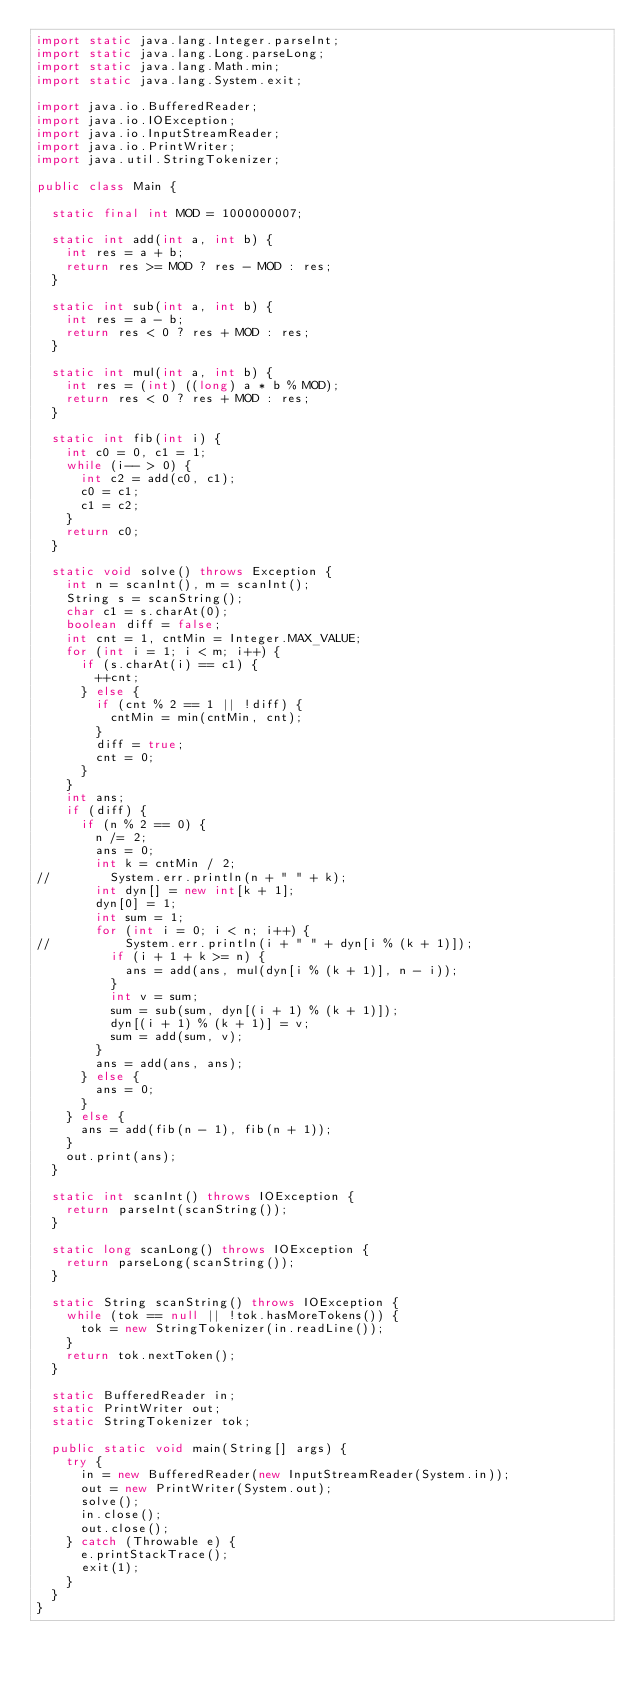<code> <loc_0><loc_0><loc_500><loc_500><_Java_>import static java.lang.Integer.parseInt;
import static java.lang.Long.parseLong;
import static java.lang.Math.min;
import static java.lang.System.exit;

import java.io.BufferedReader;
import java.io.IOException;
import java.io.InputStreamReader;
import java.io.PrintWriter;
import java.util.StringTokenizer;

public class Main {

	static final int MOD = 1000000007;

	static int add(int a, int b) {
		int res = a + b;
		return res >= MOD ? res - MOD : res;
	}

	static int sub(int a, int b) {
		int res = a - b;
		return res < 0 ? res + MOD : res;
	}

	static int mul(int a, int b) {
		int res = (int) ((long) a * b % MOD);
		return res < 0 ? res + MOD : res;
	}

	static int fib(int i) {
		int c0 = 0, c1 = 1;
		while (i-- > 0) {
			int c2 = add(c0, c1);
			c0 = c1;
			c1 = c2;
		}
		return c0;
	}

	static void solve() throws Exception {
		int n = scanInt(), m = scanInt();
		String s = scanString();
		char c1 = s.charAt(0);
		boolean diff = false;
		int cnt = 1, cntMin = Integer.MAX_VALUE;
		for (int i = 1; i < m; i++) {
			if (s.charAt(i) == c1) {
				++cnt;
			} else {
				if (cnt % 2 == 1 || !diff) {
					cntMin = min(cntMin, cnt);
				}
				diff = true;
				cnt = 0;
			}
		}
		int ans;
		if (diff) {
			if (n % 2 == 0) {
				n /= 2;
				ans = 0;
				int k = cntMin / 2;
//				System.err.println(n + " " + k);
				int dyn[] = new int[k + 1];
				dyn[0] = 1;
				int sum = 1;
				for (int i = 0; i < n; i++) {
//					System.err.println(i + " " + dyn[i % (k + 1)]);
					if (i + 1 + k >= n) {
						ans = add(ans, mul(dyn[i % (k + 1)], n - i));
					}
					int v = sum;
					sum = sub(sum, dyn[(i + 1) % (k + 1)]);
					dyn[(i + 1) % (k + 1)] = v;
					sum = add(sum, v);
				}
				ans = add(ans, ans);
			} else {
				ans = 0;
			}
		} else {
			ans = add(fib(n - 1), fib(n + 1));
		}
		out.print(ans);
	}

	static int scanInt() throws IOException {
		return parseInt(scanString());
	}

	static long scanLong() throws IOException {
		return parseLong(scanString());
	}

	static String scanString() throws IOException {
		while (tok == null || !tok.hasMoreTokens()) {
			tok = new StringTokenizer(in.readLine());
		}
		return tok.nextToken();
	}

	static BufferedReader in;
	static PrintWriter out;
	static StringTokenizer tok;

	public static void main(String[] args) {
		try {
			in = new BufferedReader(new InputStreamReader(System.in));
			out = new PrintWriter(System.out);
			solve();
			in.close();
			out.close();
		} catch (Throwable e) {
			e.printStackTrace();
			exit(1);
		}
	}
}</code> 